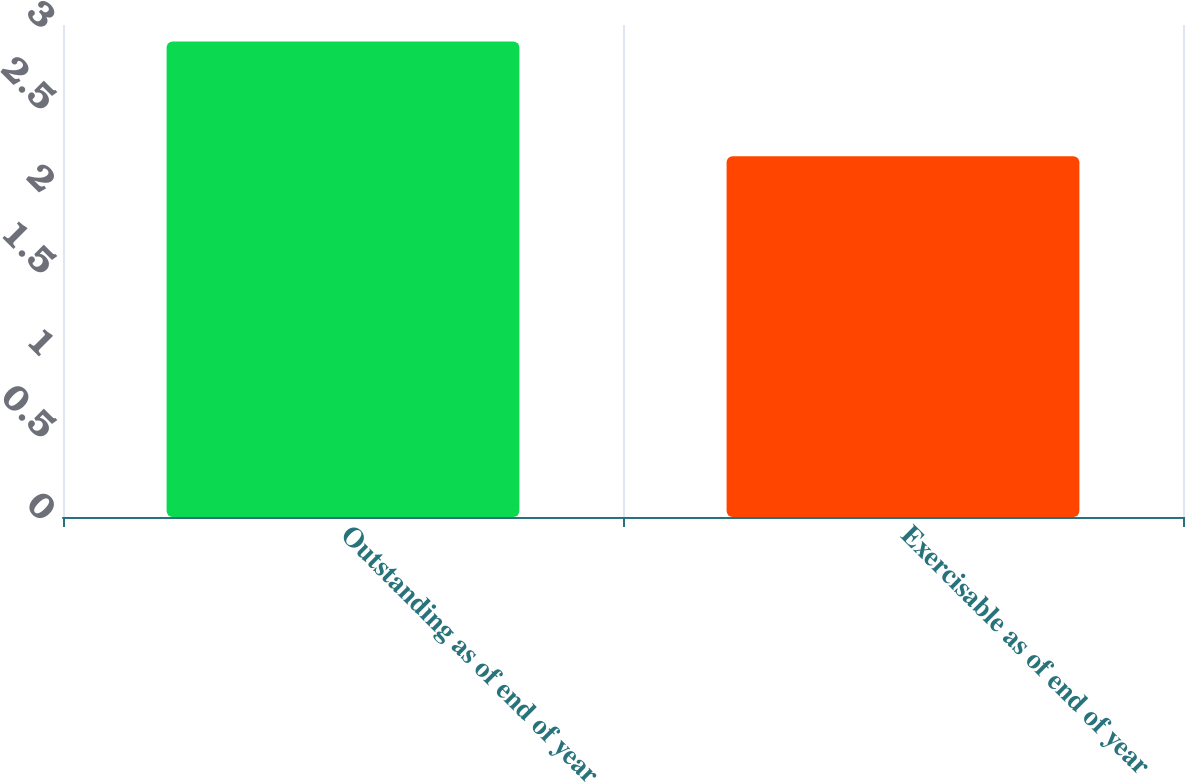Convert chart to OTSL. <chart><loc_0><loc_0><loc_500><loc_500><bar_chart><fcel>Outstanding as of end of year<fcel>Exercisable as of end of year<nl><fcel>2.9<fcel>2.2<nl></chart> 